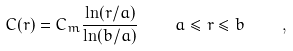Convert formula to latex. <formula><loc_0><loc_0><loc_500><loc_500>C ( r ) = C _ { m } \frac { \ln ( r / a ) } { \ln ( b / a ) } \quad a \leq r \leq b \quad ,</formula> 